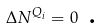<formula> <loc_0><loc_0><loc_500><loc_500>\Delta N ^ { Q _ { i } } = 0 \text { .}</formula> 